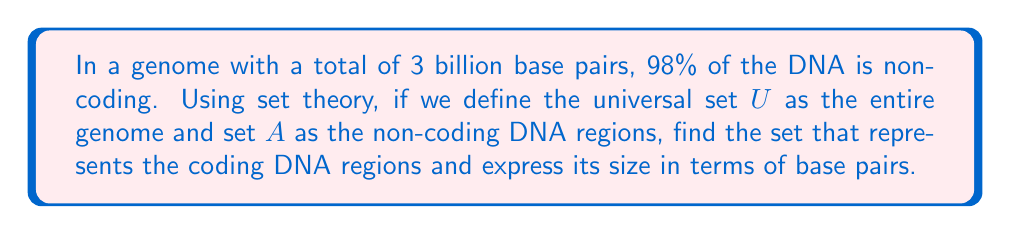Give your solution to this math problem. To solve this problem, we'll use the concept of set complement and basic set theory operations:

1) Let $U$ be the universal set representing the entire genome (3 billion base pairs).
   $|U| = 3 \times 10^9$ base pairs

2) Let $A$ be the set of non-coding DNA regions.
   Given that 98% of the DNA is non-coding:
   $|A| = 0.98 \times |U| = 0.98 \times 3 \times 10^9 = 2.94 \times 10^9$ base pairs

3) The coding DNA regions are represented by the complement of set $A$ with respect to the universal set $U$, denoted as $A^c$ or $U \setminus A$.

4) By the complement rule:
   $|A^c| = |U| - |A|$

5) Substituting the values:
   $|A^c| = 3 \times 10^9 - 2.94 \times 10^9$
   $|A^c| = 0.06 \times 10^9$
   $|A^c| = 6 \times 10^7$ base pairs

Therefore, the set representing the coding DNA regions is $A^c$, and its size is $6 \times 10^7$ base pairs.
Answer: The set representing the coding DNA regions is $A^c$ (the complement of $A$), with $|A^c| = 6 \times 10^7$ base pairs. 